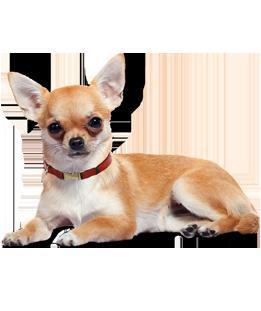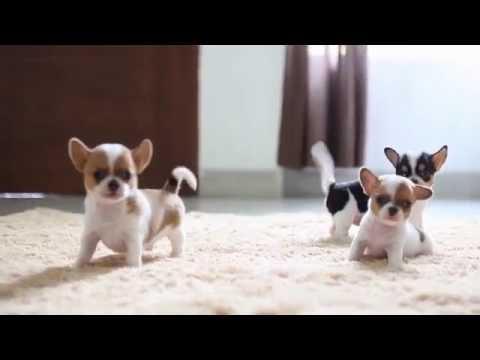The first image is the image on the left, the second image is the image on the right. Assess this claim about the two images: "A person is holding the dog in one of the images.". Correct or not? Answer yes or no. No. The first image is the image on the left, the second image is the image on the right. Assess this claim about the two images: "In total, the images contain four dogs, but do not contain the same number of dogs in each image.". Correct or not? Answer yes or no. Yes. 